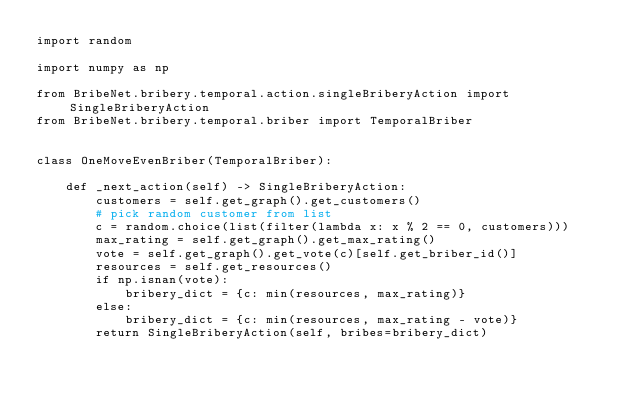<code> <loc_0><loc_0><loc_500><loc_500><_Python_>import random

import numpy as np

from BribeNet.bribery.temporal.action.singleBriberyAction import SingleBriberyAction
from BribeNet.bribery.temporal.briber import TemporalBriber


class OneMoveEvenBriber(TemporalBriber):

    def _next_action(self) -> SingleBriberyAction:
        customers = self.get_graph().get_customers()
        # pick random customer from list
        c = random.choice(list(filter(lambda x: x % 2 == 0, customers)))
        max_rating = self.get_graph().get_max_rating()
        vote = self.get_graph().get_vote(c)[self.get_briber_id()]
        resources = self.get_resources()
        if np.isnan(vote):
            bribery_dict = {c: min(resources, max_rating)}
        else:
            bribery_dict = {c: min(resources, max_rating - vote)}
        return SingleBriberyAction(self, bribes=bribery_dict)
</code> 